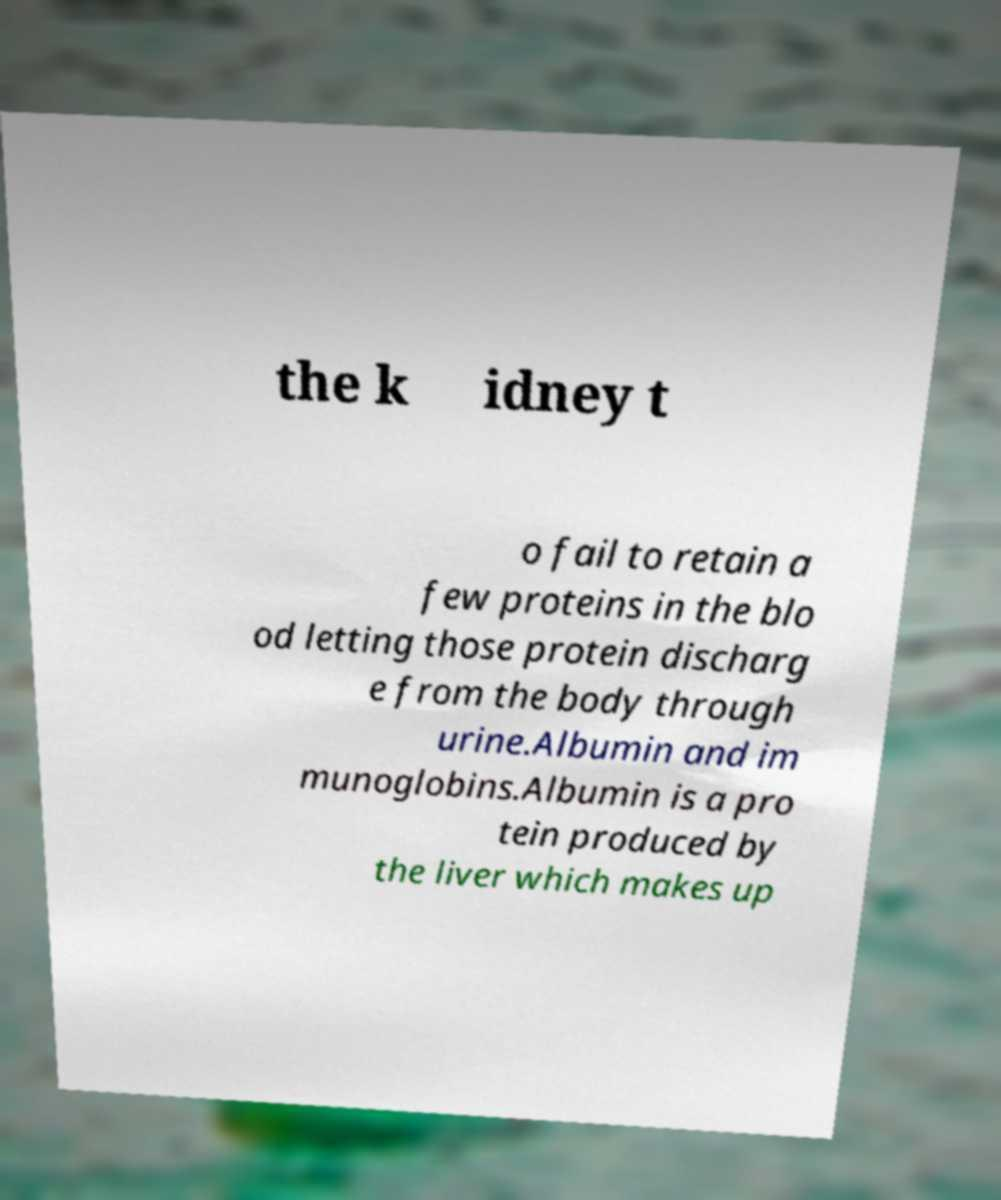Please read and relay the text visible in this image. What does it say? the k idney t o fail to retain a few proteins in the blo od letting those protein discharg e from the body through urine.Albumin and im munoglobins.Albumin is a pro tein produced by the liver which makes up 